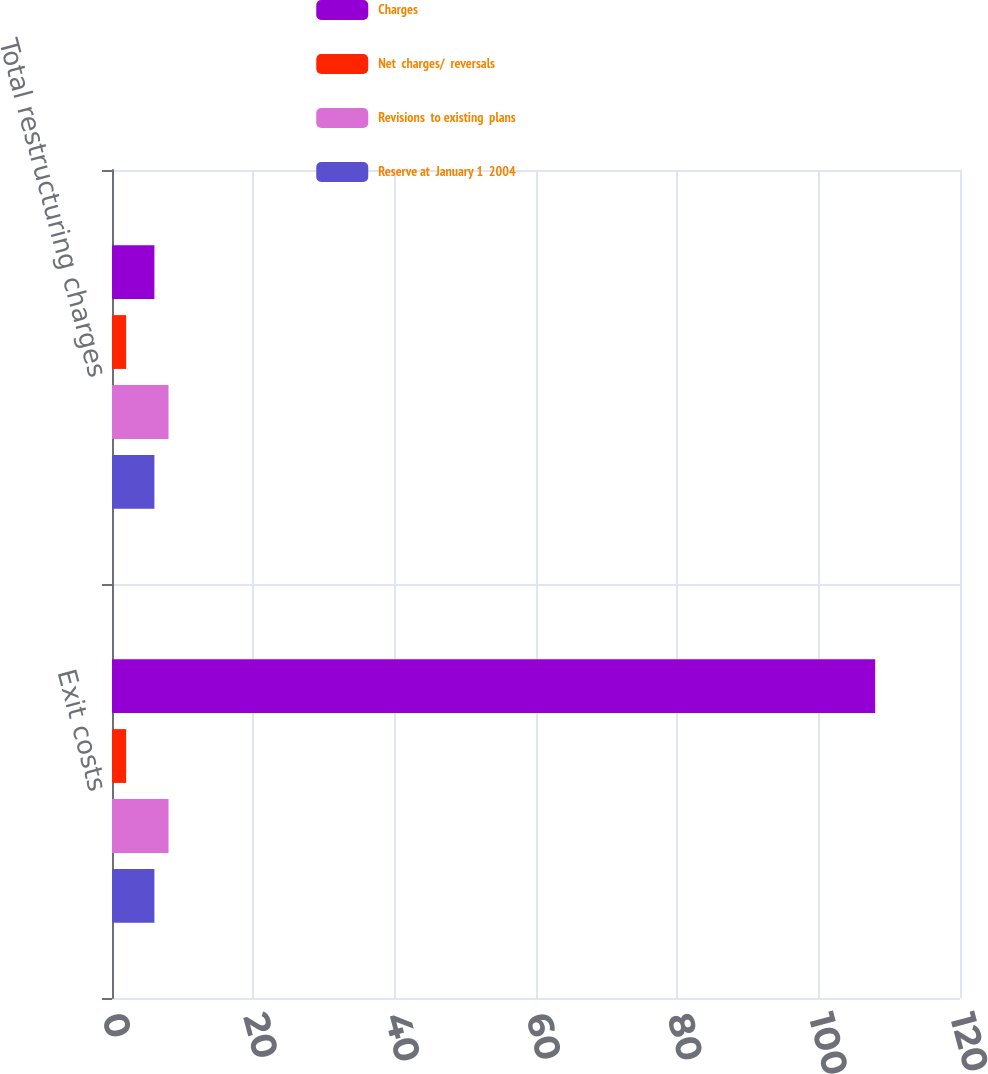Convert chart to OTSL. <chart><loc_0><loc_0><loc_500><loc_500><stacked_bar_chart><ecel><fcel>Exit costs<fcel>Total restructuring charges<nl><fcel>Charges<fcel>108<fcel>6<nl><fcel>Net  charges/  reversals<fcel>2<fcel>2<nl><fcel>Revisions  to existing  plans<fcel>8<fcel>8<nl><fcel>Reserve at  January 1  2004<fcel>6<fcel>6<nl></chart> 